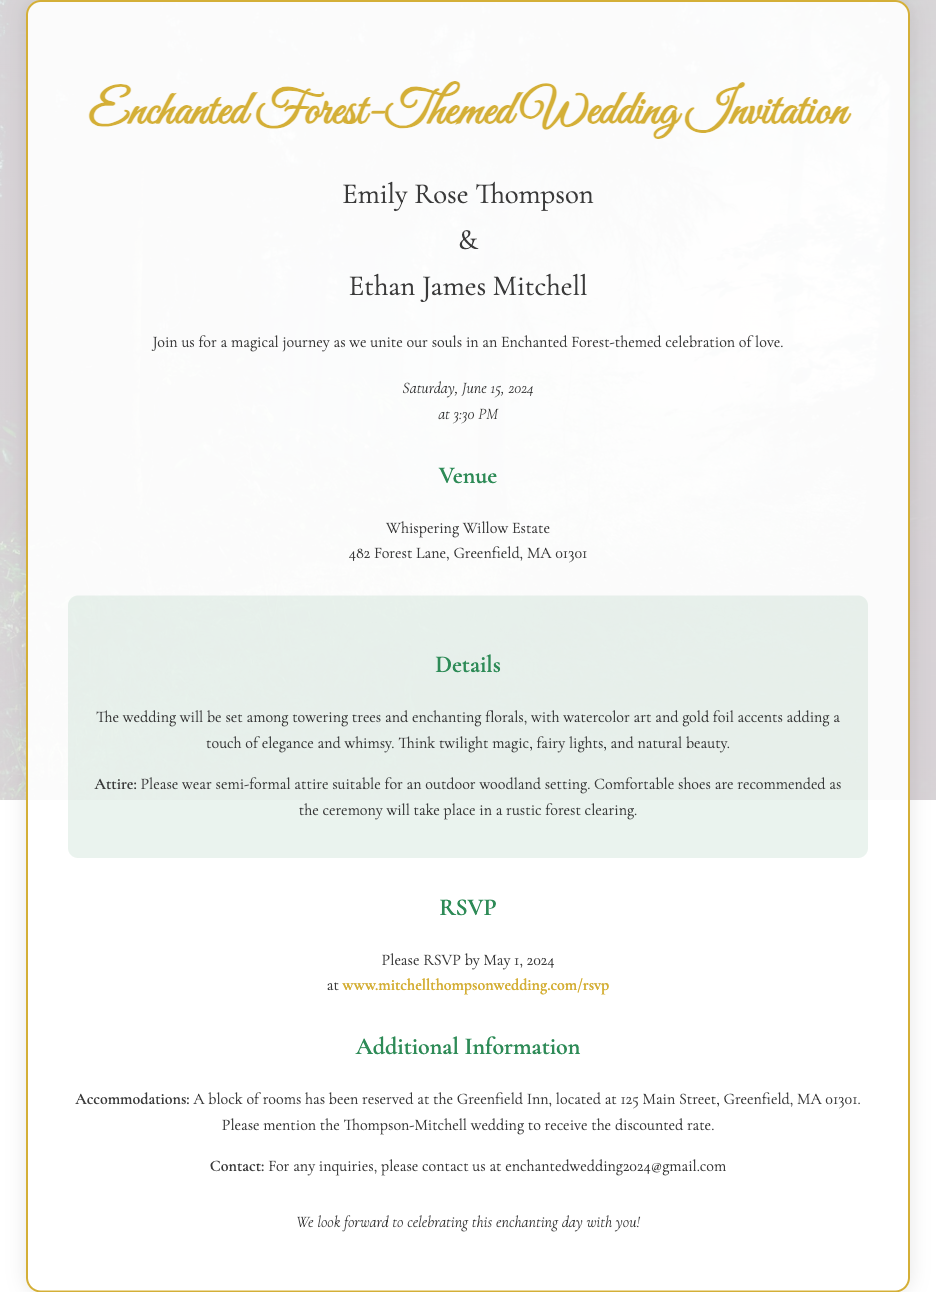What are the names of the couple? The names of the couple are explicitly stated in the invitation text.
Answer: Emily Rose Thompson and Ethan James Mitchell What is the date of the wedding? The document specifies the date of the wedding in the date-time section.
Answer: June 15, 2024 Where is the wedding venue? The venue is provided in a dedicated section of the invitation.
Answer: Whispering Willow Estate What time does the wedding start? The starting time is mentioned alongside the date in the date-time section.
Answer: 3:30 PM What type of attire is suggested for the guests? The invitation includes a note about the desired attire for the wedding.
Answer: Semi-formal attire When is the RSVP deadline? The RSVP deadline is clearly mentioned in the RSVP section.
Answer: May 1, 2024 What should guests mention for accommodations? The additional information section provides guidance for booking accommodations.
Answer: Thompson-Mitchell wedding What is the contact email for inquiries? The contact email is provided in the additional information section of the invitation.
Answer: enchantedwedding2024@gmail.com What theme is the wedding based on? The wedding's theme is highlighted in the title and introductory text of the invitation.
Answer: Enchanted Forest-themed 